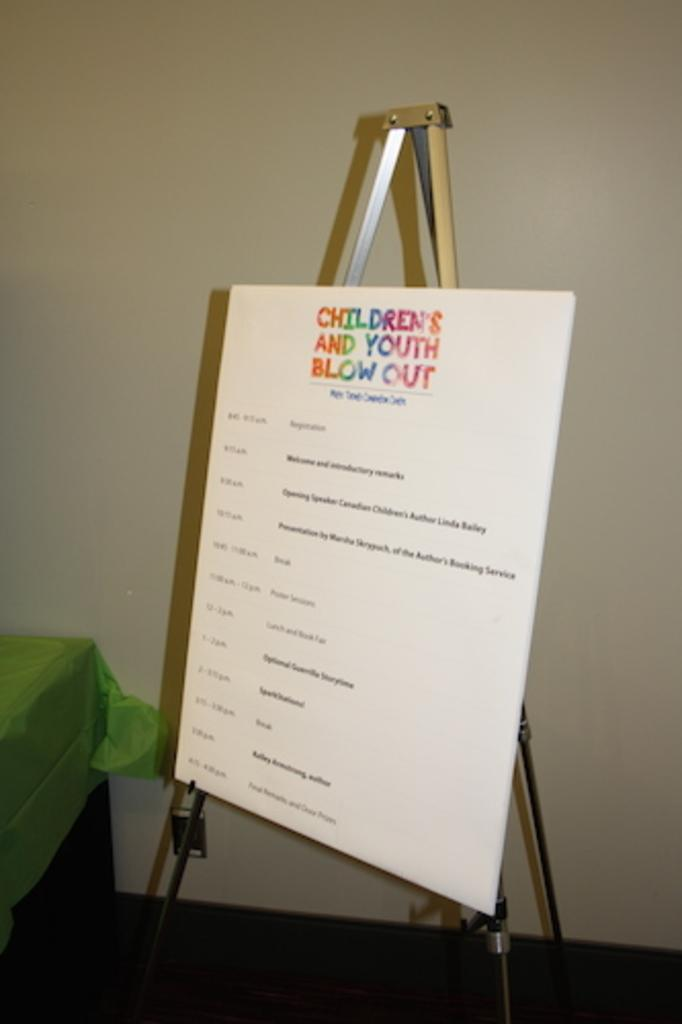<image>
Relay a brief, clear account of the picture shown. A poster on an easel that says, "children's and youth blow out". 